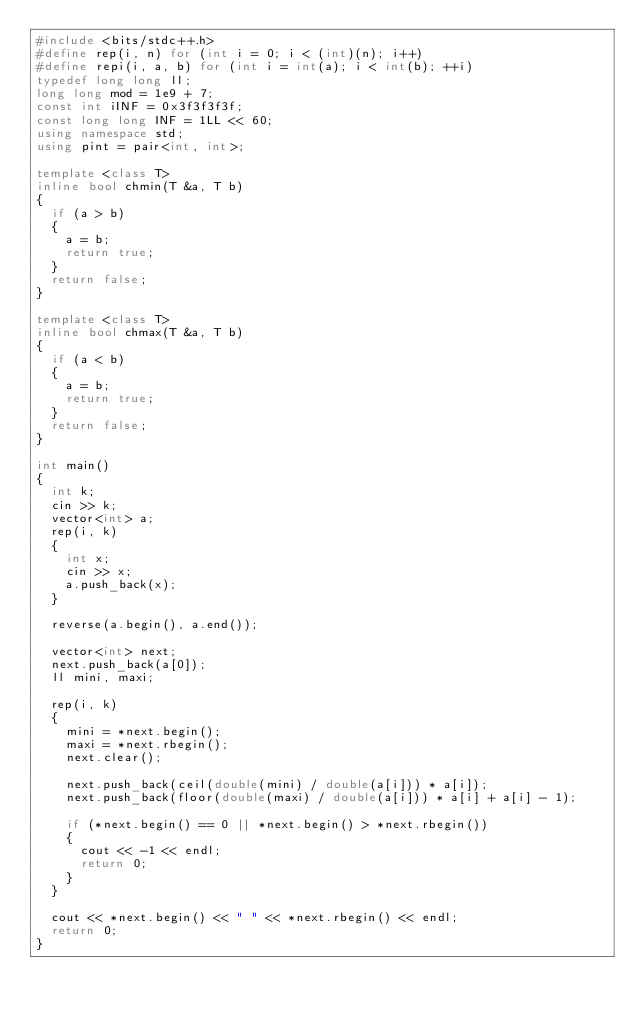Convert code to text. <code><loc_0><loc_0><loc_500><loc_500><_C++_>#include <bits/stdc++.h>
#define rep(i, n) for (int i = 0; i < (int)(n); i++)
#define repi(i, a, b) for (int i = int(a); i < int(b); ++i)
typedef long long ll;
long long mod = 1e9 + 7;
const int iINF = 0x3f3f3f3f;
const long long INF = 1LL << 60;
using namespace std;
using pint = pair<int, int>;

template <class T>
inline bool chmin(T &a, T b)
{
  if (a > b)
  {
    a = b;
    return true;
  }
  return false;
}

template <class T>
inline bool chmax(T &a, T b)
{
  if (a < b)
  {
    a = b;
    return true;
  }
  return false;
}

int main()
{
  int k;
  cin >> k;
  vector<int> a;
  rep(i, k)
  {
    int x;
    cin >> x;
    a.push_back(x);
  }

  reverse(a.begin(), a.end());

  vector<int> next;
  next.push_back(a[0]);
  ll mini, maxi;

  rep(i, k)
  {
    mini = *next.begin();
    maxi = *next.rbegin();
    next.clear();

    next.push_back(ceil(double(mini) / double(a[i])) * a[i]);
    next.push_back(floor(double(maxi) / double(a[i])) * a[i] + a[i] - 1);

    if (*next.begin() == 0 || *next.begin() > *next.rbegin())
    {
      cout << -1 << endl;
      return 0;
    }
  }

  cout << *next.begin() << " " << *next.rbegin() << endl;
  return 0;
}
</code> 